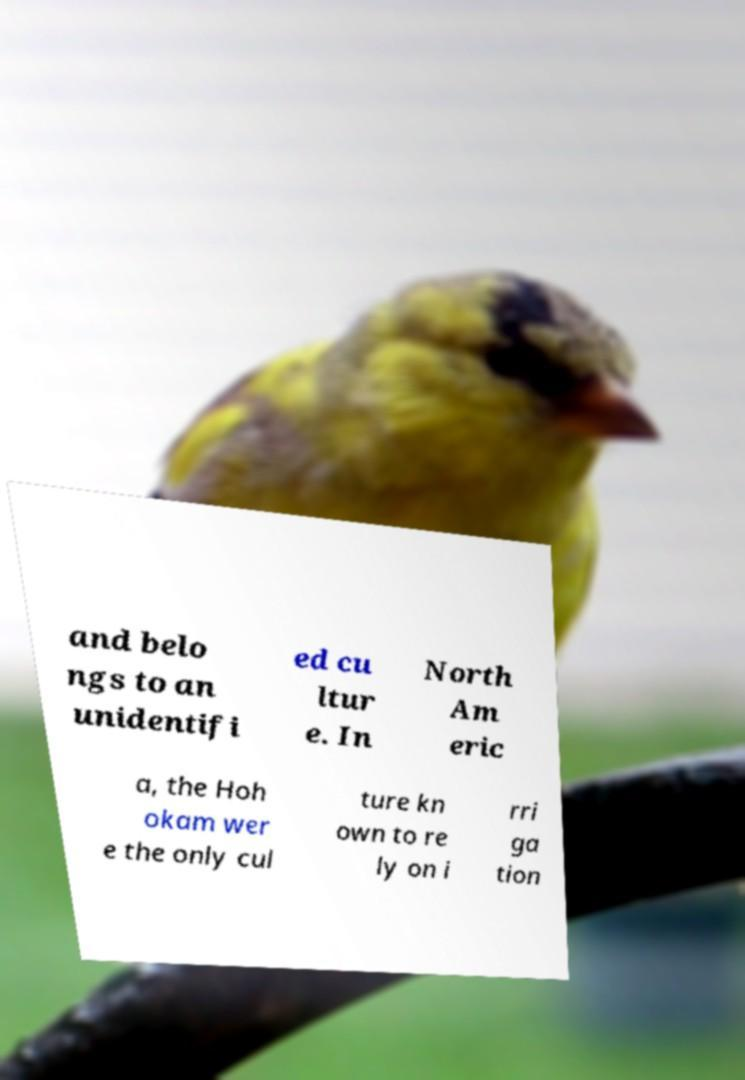Please read and relay the text visible in this image. What does it say? and belo ngs to an unidentifi ed cu ltur e. In North Am eric a, the Hoh okam wer e the only cul ture kn own to re ly on i rri ga tion 